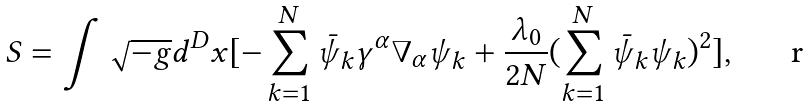<formula> <loc_0><loc_0><loc_500><loc_500>S = \int \sqrt { - g } d ^ { D } x [ - \sum _ { k = 1 } ^ { N } \bar { \psi } _ { k } \gamma ^ { \alpha } \nabla _ { \alpha } \psi _ { k } + \frac { \lambda _ { 0 } } { 2 N } ( \sum _ { k = 1 } ^ { N } \bar { \psi } _ { k } \psi _ { k } ) ^ { 2 } ] ,</formula> 